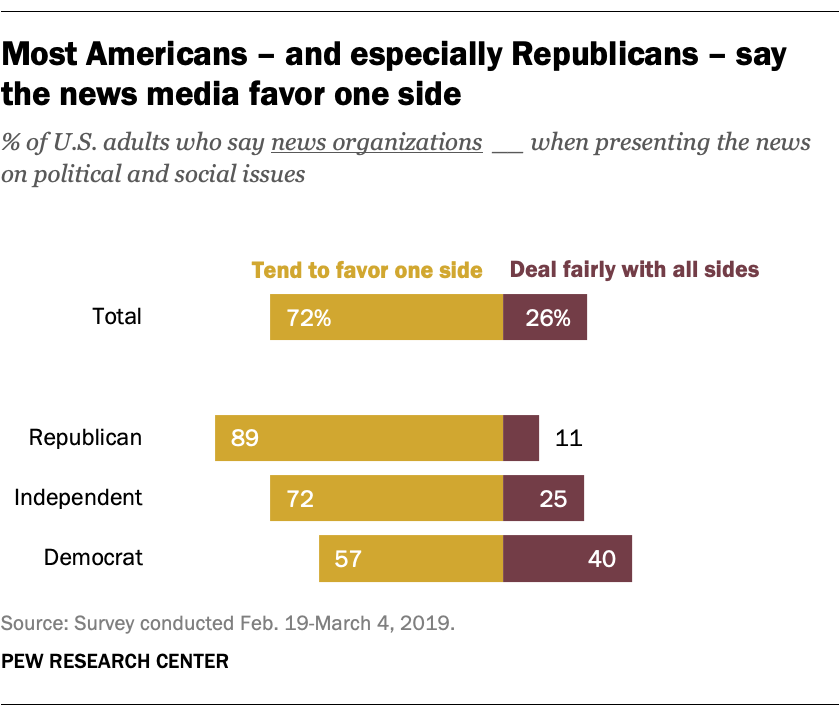Highlight a few significant elements in this photo. What is the minimum permissible value for the right bar in state X? The ratio between the least favorable percentage and the most favorable percentage for a deal is 2.402777778... 